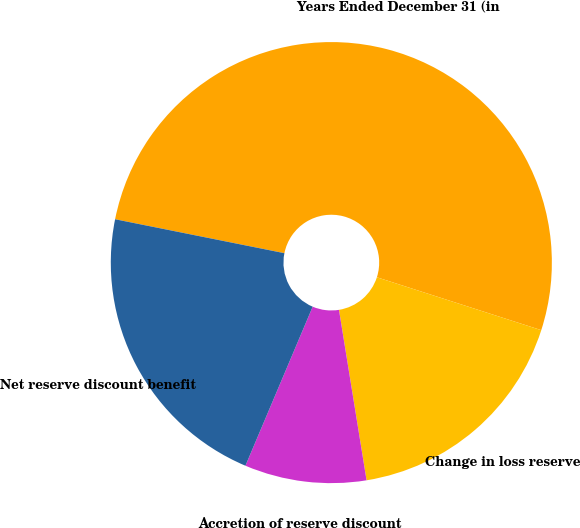Convert chart. <chart><loc_0><loc_0><loc_500><loc_500><pie_chart><fcel>Years Ended December 31 (in<fcel>Change in loss reserve<fcel>Accretion of reserve discount<fcel>Net reserve discount benefit<nl><fcel>51.8%<fcel>17.49%<fcel>8.92%<fcel>21.78%<nl></chart> 